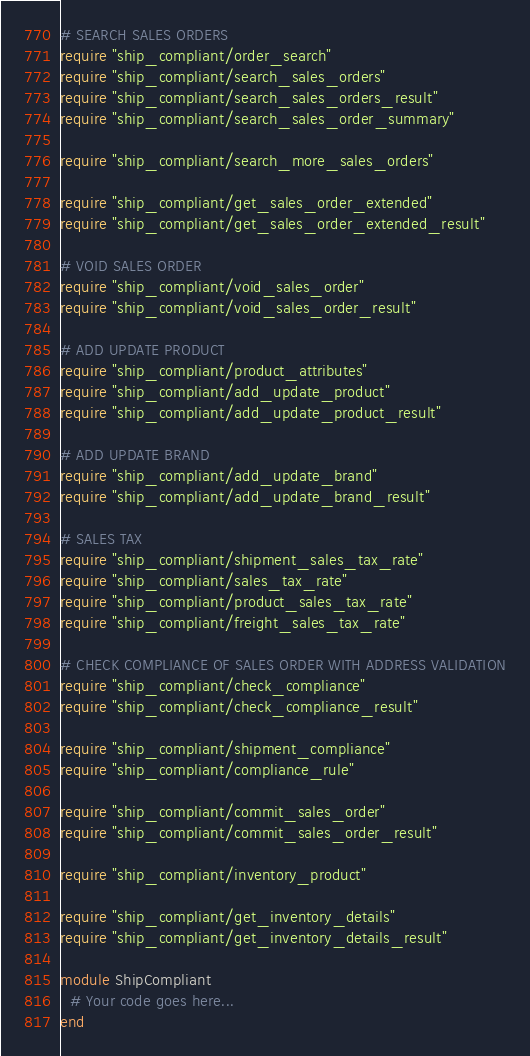Convert code to text. <code><loc_0><loc_0><loc_500><loc_500><_Ruby_># SEARCH SALES ORDERS
require "ship_compliant/order_search"
require "ship_compliant/search_sales_orders"
require "ship_compliant/search_sales_orders_result"
require "ship_compliant/search_sales_order_summary"

require "ship_compliant/search_more_sales_orders"

require "ship_compliant/get_sales_order_extended"
require "ship_compliant/get_sales_order_extended_result"

# VOID SALES ORDER
require "ship_compliant/void_sales_order"
require "ship_compliant/void_sales_order_result"

# ADD UPDATE PRODUCT
require "ship_compliant/product_attributes"
require "ship_compliant/add_update_product"
require "ship_compliant/add_update_product_result"

# ADD UPDATE BRAND
require "ship_compliant/add_update_brand"
require "ship_compliant/add_update_brand_result"

# SALES TAX
require "ship_compliant/shipment_sales_tax_rate"
require "ship_compliant/sales_tax_rate"
require "ship_compliant/product_sales_tax_rate"
require "ship_compliant/freight_sales_tax_rate"

# CHECK COMPLIANCE OF SALES ORDER WITH ADDRESS VALIDATION
require "ship_compliant/check_compliance"
require "ship_compliant/check_compliance_result"

require "ship_compliant/shipment_compliance"
require "ship_compliant/compliance_rule"

require "ship_compliant/commit_sales_order"
require "ship_compliant/commit_sales_order_result"

require "ship_compliant/inventory_product"

require "ship_compliant/get_inventory_details"
require "ship_compliant/get_inventory_details_result"

module ShipCompliant
  # Your code goes here...
end
</code> 